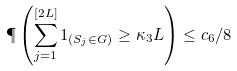Convert formula to latex. <formula><loc_0><loc_0><loc_500><loc_500>\P \left ( \sum _ { j = 1 } ^ { [ 2 L ] } 1 _ { ( S _ { j } \in G ) } \geq \kappa _ { 3 } L \right ) \leq c _ { 6 } / 8</formula> 